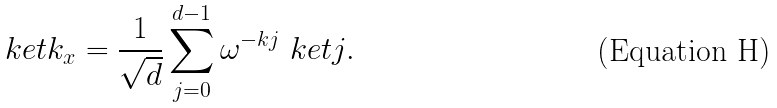<formula> <loc_0><loc_0><loc_500><loc_500>\ k e t { k _ { x } } = \frac { 1 } { \sqrt { d } } \sum _ { j = 0 } ^ { d - 1 } \omega ^ { - k j } \ k e t { j } .</formula> 